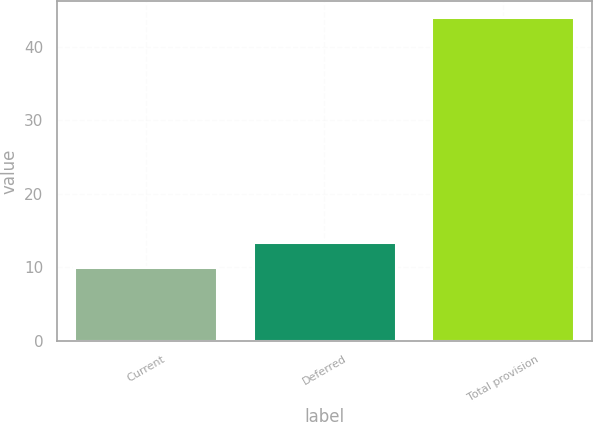Convert chart to OTSL. <chart><loc_0><loc_0><loc_500><loc_500><bar_chart><fcel>Current<fcel>Deferred<fcel>Total provision<nl><fcel>10<fcel>13.4<fcel>44<nl></chart> 